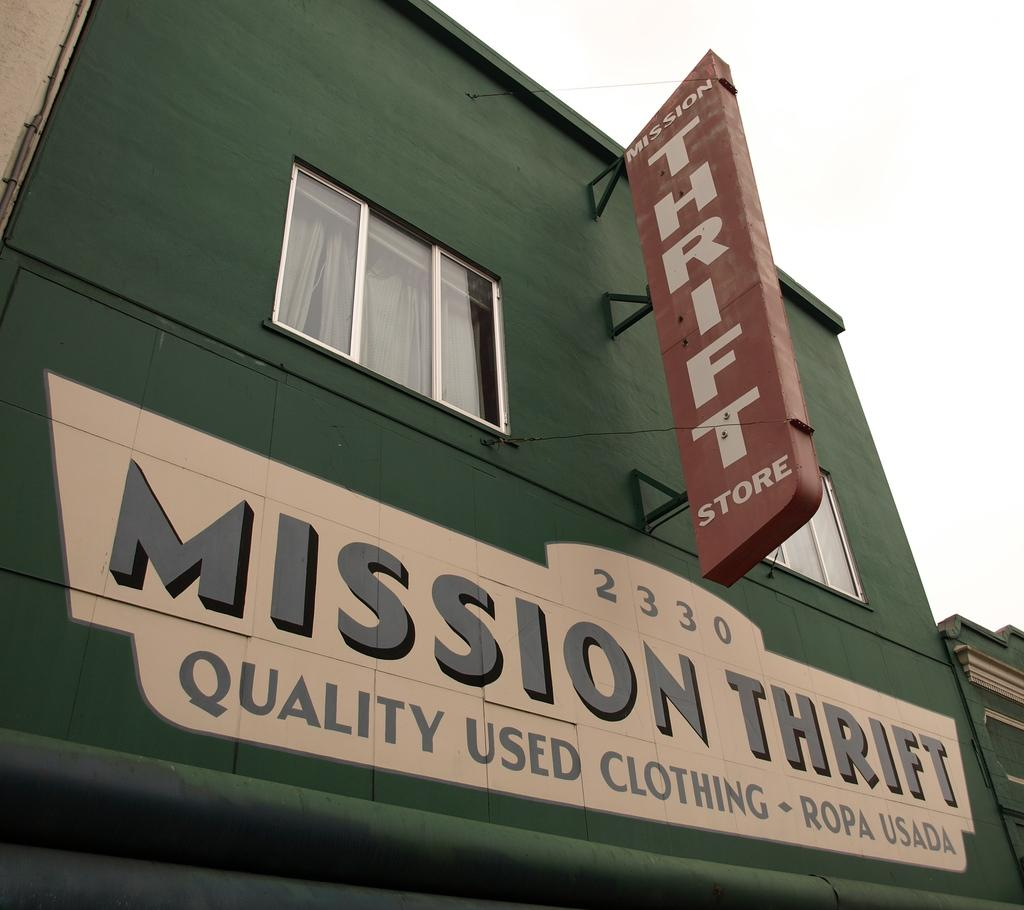What type of structures can be seen in the image? There are buildings in the image. Can you describe any specific features of one of the buildings? One of the buildings has a shop board with the words "mission thrift" painted on it. What color is the building with the shop board? The building with the shop board has a green color and a glass window. Can you tell me how many maids are working in the building with the shop board? There is no information about maids in the image, as it only shows buildings and their features. 